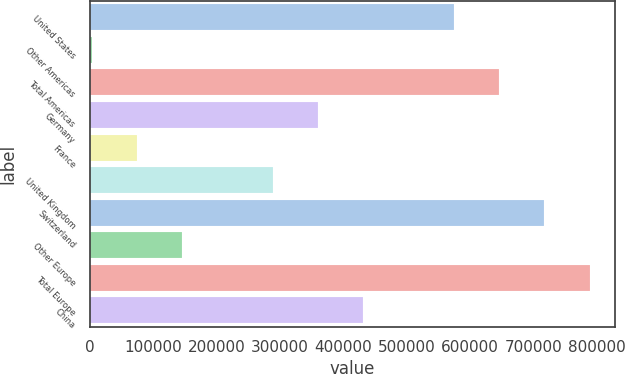Convert chart. <chart><loc_0><loc_0><loc_500><loc_500><bar_chart><fcel>United States<fcel>Other Americas<fcel>Total Americas<fcel>Germany<fcel>France<fcel>United Kingdom<fcel>Switzerland<fcel>Other Europe<fcel>Total Europe<fcel>China<nl><fcel>574610<fcel>2946<fcel>646068<fcel>360236<fcel>74404<fcel>288778<fcel>717526<fcel>145862<fcel>788984<fcel>431694<nl></chart> 